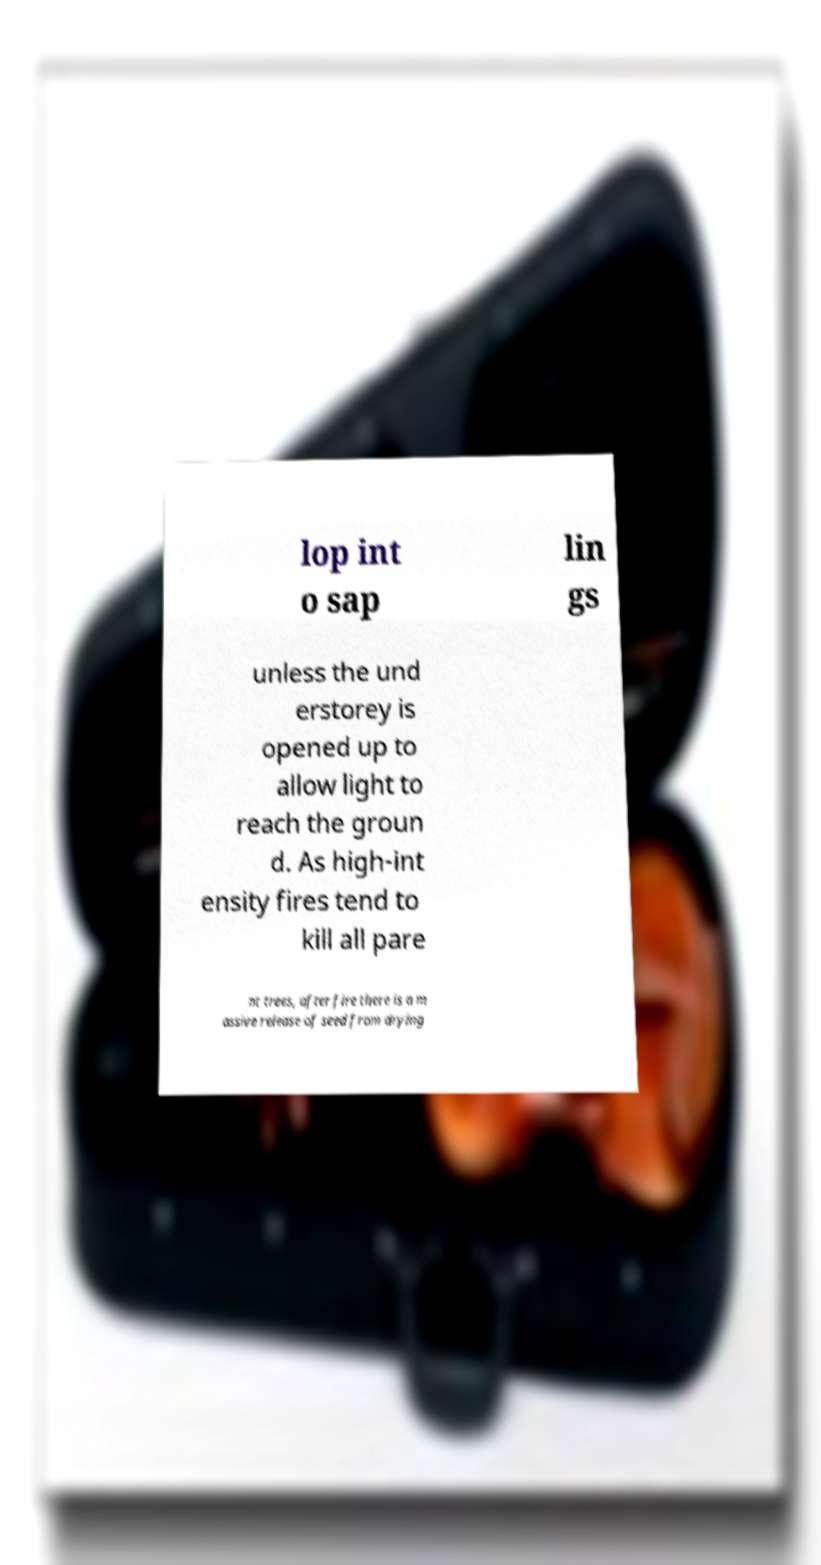Please identify and transcribe the text found in this image. lop int o sap lin gs unless the und erstorey is opened up to allow light to reach the groun d. As high-int ensity fires tend to kill all pare nt trees, after fire there is a m assive release of seed from drying 